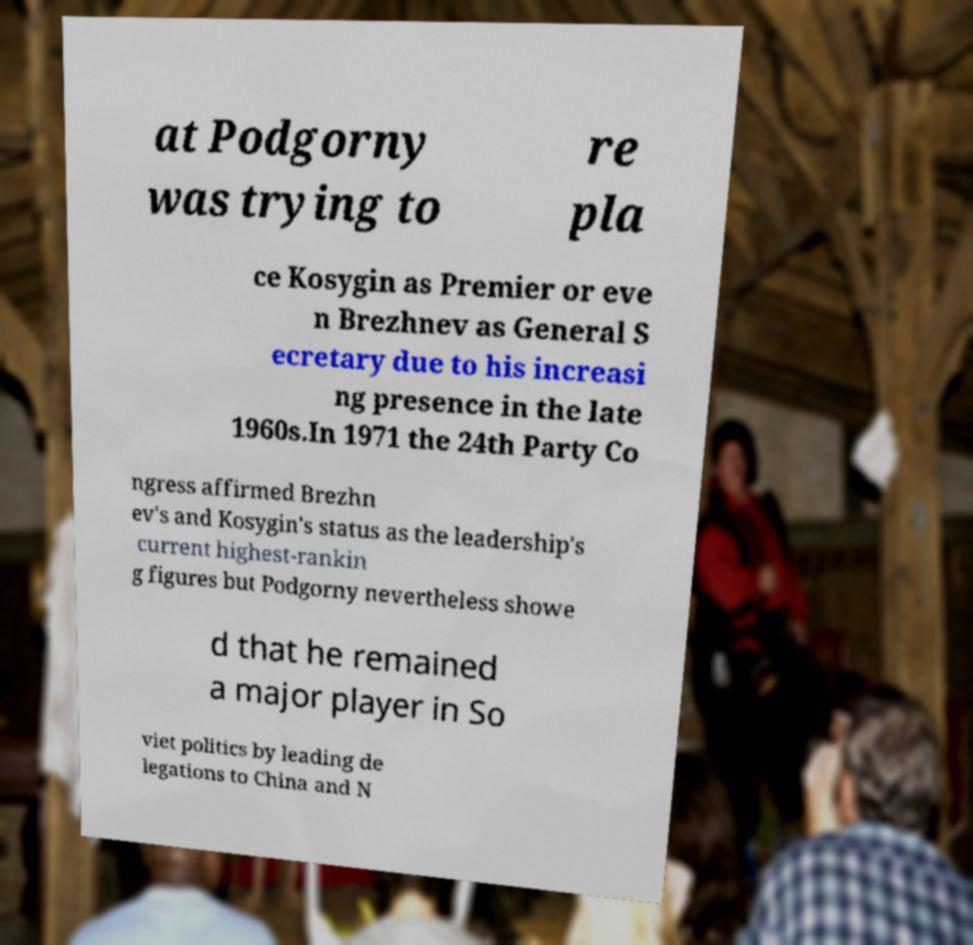There's text embedded in this image that I need extracted. Can you transcribe it verbatim? at Podgorny was trying to re pla ce Kosygin as Premier or eve n Brezhnev as General S ecretary due to his increasi ng presence in the late 1960s.In 1971 the 24th Party Co ngress affirmed Brezhn ev's and Kosygin's status as the leadership's current highest-rankin g figures but Podgorny nevertheless showe d that he remained a major player in So viet politics by leading de legations to China and N 